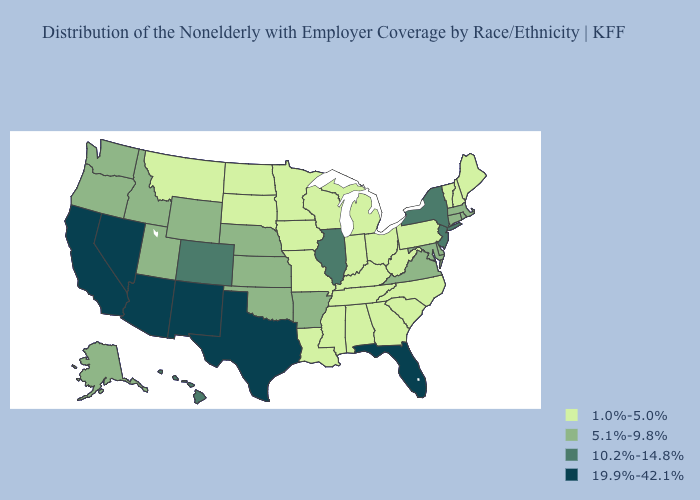Does Minnesota have the highest value in the MidWest?
Concise answer only. No. What is the value of Missouri?
Be succinct. 1.0%-5.0%. Among the states that border Idaho , does Nevada have the lowest value?
Write a very short answer. No. Among the states that border Iowa , which have the highest value?
Concise answer only. Illinois. Does Arizona have the highest value in the West?
Be succinct. Yes. What is the value of Kansas?
Give a very brief answer. 5.1%-9.8%. Which states have the highest value in the USA?
Answer briefly. Arizona, California, Florida, Nevada, New Mexico, Texas. Which states hav the highest value in the Northeast?
Write a very short answer. New Jersey, New York. Does Alabama have the highest value in the South?
Concise answer only. No. What is the highest value in states that border Rhode Island?
Short answer required. 5.1%-9.8%. What is the value of Virginia?
Concise answer only. 5.1%-9.8%. Which states have the lowest value in the USA?
Write a very short answer. Alabama, Georgia, Indiana, Iowa, Kentucky, Louisiana, Maine, Michigan, Minnesota, Mississippi, Missouri, Montana, New Hampshire, North Carolina, North Dakota, Ohio, Pennsylvania, South Carolina, South Dakota, Tennessee, Vermont, West Virginia, Wisconsin. What is the value of Idaho?
Short answer required. 5.1%-9.8%. What is the value of New Hampshire?
Quick response, please. 1.0%-5.0%. 